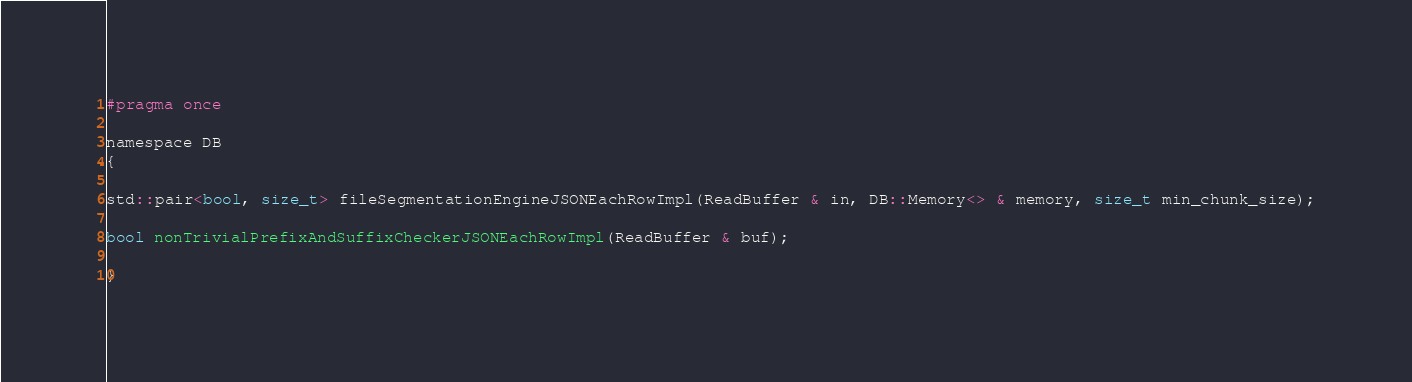Convert code to text. <code><loc_0><loc_0><loc_500><loc_500><_C_>#pragma once

namespace DB
{

std::pair<bool, size_t> fileSegmentationEngineJSONEachRowImpl(ReadBuffer & in, DB::Memory<> & memory, size_t min_chunk_size);

bool nonTrivialPrefixAndSuffixCheckerJSONEachRowImpl(ReadBuffer & buf);

}
</code> 